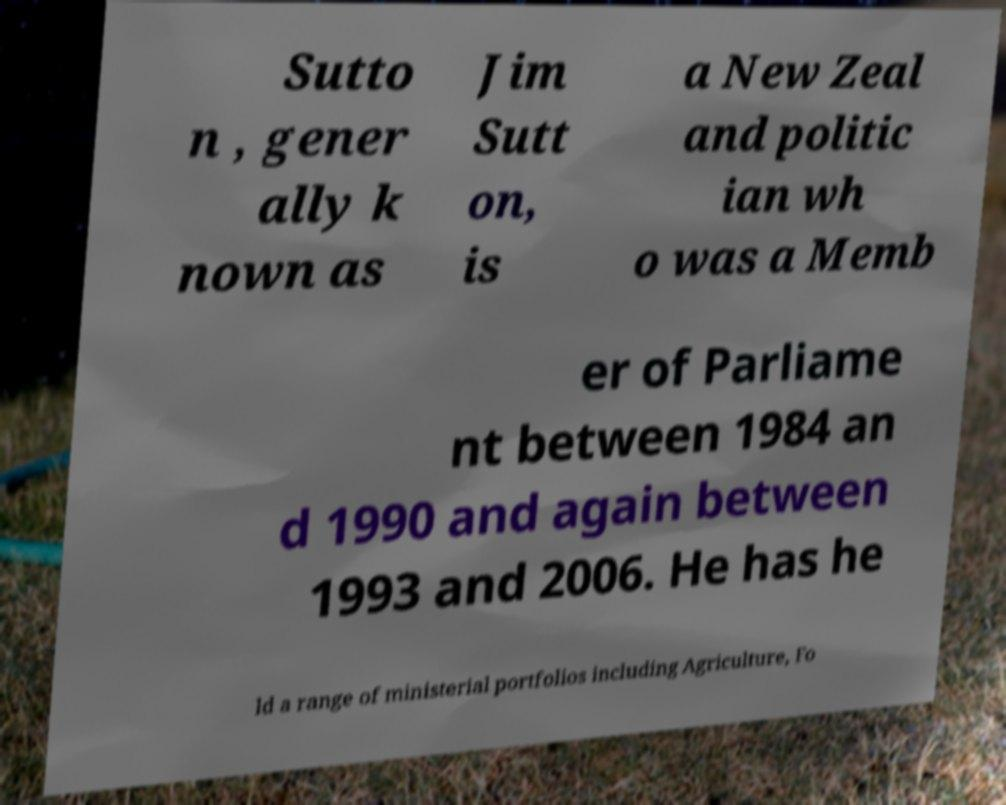Could you assist in decoding the text presented in this image and type it out clearly? Sutto n , gener ally k nown as Jim Sutt on, is a New Zeal and politic ian wh o was a Memb er of Parliame nt between 1984 an d 1990 and again between 1993 and 2006. He has he ld a range of ministerial portfolios including Agriculture, Fo 